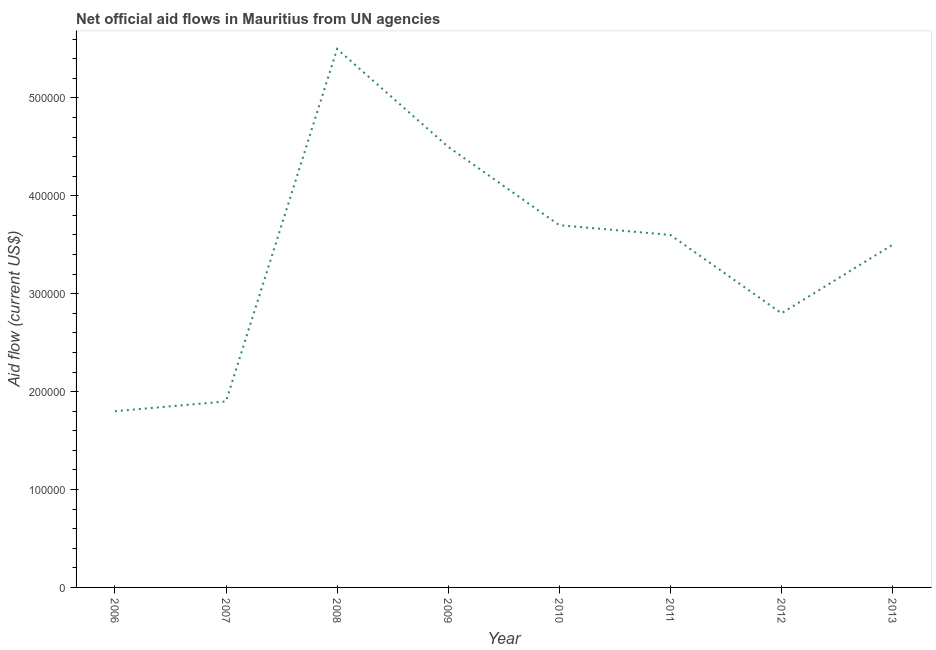What is the net official flows from un agencies in 2011?
Keep it short and to the point. 3.60e+05. Across all years, what is the maximum net official flows from un agencies?
Your answer should be very brief. 5.50e+05. Across all years, what is the minimum net official flows from un agencies?
Give a very brief answer. 1.80e+05. In which year was the net official flows from un agencies maximum?
Provide a succinct answer. 2008. What is the sum of the net official flows from un agencies?
Make the answer very short. 2.73e+06. What is the difference between the net official flows from un agencies in 2006 and 2010?
Keep it short and to the point. -1.90e+05. What is the average net official flows from un agencies per year?
Offer a terse response. 3.41e+05. What is the median net official flows from un agencies?
Offer a terse response. 3.55e+05. In how many years, is the net official flows from un agencies greater than 260000 US$?
Your answer should be very brief. 6. Do a majority of the years between 2007 and 2008 (inclusive) have net official flows from un agencies greater than 180000 US$?
Provide a succinct answer. Yes. What is the ratio of the net official flows from un agencies in 2007 to that in 2008?
Your response must be concise. 0.35. Is the difference between the net official flows from un agencies in 2006 and 2012 greater than the difference between any two years?
Ensure brevity in your answer.  No. What is the difference between the highest and the second highest net official flows from un agencies?
Keep it short and to the point. 1.00e+05. What is the difference between the highest and the lowest net official flows from un agencies?
Keep it short and to the point. 3.70e+05. In how many years, is the net official flows from un agencies greater than the average net official flows from un agencies taken over all years?
Make the answer very short. 5. Does the net official flows from un agencies monotonically increase over the years?
Ensure brevity in your answer.  No. How many lines are there?
Offer a terse response. 1. What is the difference between two consecutive major ticks on the Y-axis?
Provide a short and direct response. 1.00e+05. Does the graph contain grids?
Your answer should be compact. No. What is the title of the graph?
Keep it short and to the point. Net official aid flows in Mauritius from UN agencies. What is the Aid flow (current US$) of 2006?
Offer a very short reply. 1.80e+05. What is the Aid flow (current US$) of 2007?
Offer a very short reply. 1.90e+05. What is the Aid flow (current US$) of 2008?
Your answer should be compact. 5.50e+05. What is the Aid flow (current US$) in 2009?
Your answer should be compact. 4.50e+05. What is the Aid flow (current US$) in 2010?
Offer a terse response. 3.70e+05. What is the difference between the Aid flow (current US$) in 2006 and 2007?
Your answer should be very brief. -10000. What is the difference between the Aid flow (current US$) in 2006 and 2008?
Offer a terse response. -3.70e+05. What is the difference between the Aid flow (current US$) in 2006 and 2009?
Give a very brief answer. -2.70e+05. What is the difference between the Aid flow (current US$) in 2006 and 2010?
Ensure brevity in your answer.  -1.90e+05. What is the difference between the Aid flow (current US$) in 2007 and 2008?
Keep it short and to the point. -3.60e+05. What is the difference between the Aid flow (current US$) in 2007 and 2009?
Keep it short and to the point. -2.60e+05. What is the difference between the Aid flow (current US$) in 2007 and 2010?
Your answer should be compact. -1.80e+05. What is the difference between the Aid flow (current US$) in 2007 and 2012?
Offer a very short reply. -9.00e+04. What is the difference between the Aid flow (current US$) in 2007 and 2013?
Offer a very short reply. -1.60e+05. What is the difference between the Aid flow (current US$) in 2008 and 2009?
Your response must be concise. 1.00e+05. What is the difference between the Aid flow (current US$) in 2008 and 2011?
Your answer should be compact. 1.90e+05. What is the difference between the Aid flow (current US$) in 2008 and 2012?
Your answer should be very brief. 2.70e+05. What is the difference between the Aid flow (current US$) in 2009 and 2011?
Your response must be concise. 9.00e+04. What is the difference between the Aid flow (current US$) in 2009 and 2013?
Offer a very short reply. 1.00e+05. What is the difference between the Aid flow (current US$) in 2010 and 2011?
Provide a short and direct response. 10000. What is the difference between the Aid flow (current US$) in 2010 and 2012?
Ensure brevity in your answer.  9.00e+04. What is the difference between the Aid flow (current US$) in 2010 and 2013?
Provide a succinct answer. 2.00e+04. What is the difference between the Aid flow (current US$) in 2012 and 2013?
Keep it short and to the point. -7.00e+04. What is the ratio of the Aid flow (current US$) in 2006 to that in 2007?
Provide a succinct answer. 0.95. What is the ratio of the Aid flow (current US$) in 2006 to that in 2008?
Provide a succinct answer. 0.33. What is the ratio of the Aid flow (current US$) in 2006 to that in 2009?
Provide a succinct answer. 0.4. What is the ratio of the Aid flow (current US$) in 2006 to that in 2010?
Your response must be concise. 0.49. What is the ratio of the Aid flow (current US$) in 2006 to that in 2012?
Your answer should be compact. 0.64. What is the ratio of the Aid flow (current US$) in 2006 to that in 2013?
Provide a succinct answer. 0.51. What is the ratio of the Aid flow (current US$) in 2007 to that in 2008?
Your answer should be very brief. 0.34. What is the ratio of the Aid flow (current US$) in 2007 to that in 2009?
Make the answer very short. 0.42. What is the ratio of the Aid flow (current US$) in 2007 to that in 2010?
Provide a short and direct response. 0.51. What is the ratio of the Aid flow (current US$) in 2007 to that in 2011?
Offer a terse response. 0.53. What is the ratio of the Aid flow (current US$) in 2007 to that in 2012?
Ensure brevity in your answer.  0.68. What is the ratio of the Aid flow (current US$) in 2007 to that in 2013?
Provide a succinct answer. 0.54. What is the ratio of the Aid flow (current US$) in 2008 to that in 2009?
Offer a terse response. 1.22. What is the ratio of the Aid flow (current US$) in 2008 to that in 2010?
Your answer should be compact. 1.49. What is the ratio of the Aid flow (current US$) in 2008 to that in 2011?
Offer a terse response. 1.53. What is the ratio of the Aid flow (current US$) in 2008 to that in 2012?
Offer a terse response. 1.96. What is the ratio of the Aid flow (current US$) in 2008 to that in 2013?
Provide a short and direct response. 1.57. What is the ratio of the Aid flow (current US$) in 2009 to that in 2010?
Your answer should be very brief. 1.22. What is the ratio of the Aid flow (current US$) in 2009 to that in 2011?
Your answer should be very brief. 1.25. What is the ratio of the Aid flow (current US$) in 2009 to that in 2012?
Your response must be concise. 1.61. What is the ratio of the Aid flow (current US$) in 2009 to that in 2013?
Give a very brief answer. 1.29. What is the ratio of the Aid flow (current US$) in 2010 to that in 2011?
Keep it short and to the point. 1.03. What is the ratio of the Aid flow (current US$) in 2010 to that in 2012?
Your response must be concise. 1.32. What is the ratio of the Aid flow (current US$) in 2010 to that in 2013?
Offer a very short reply. 1.06. What is the ratio of the Aid flow (current US$) in 2011 to that in 2012?
Offer a terse response. 1.29. What is the ratio of the Aid flow (current US$) in 2011 to that in 2013?
Offer a terse response. 1.03. What is the ratio of the Aid flow (current US$) in 2012 to that in 2013?
Your response must be concise. 0.8. 